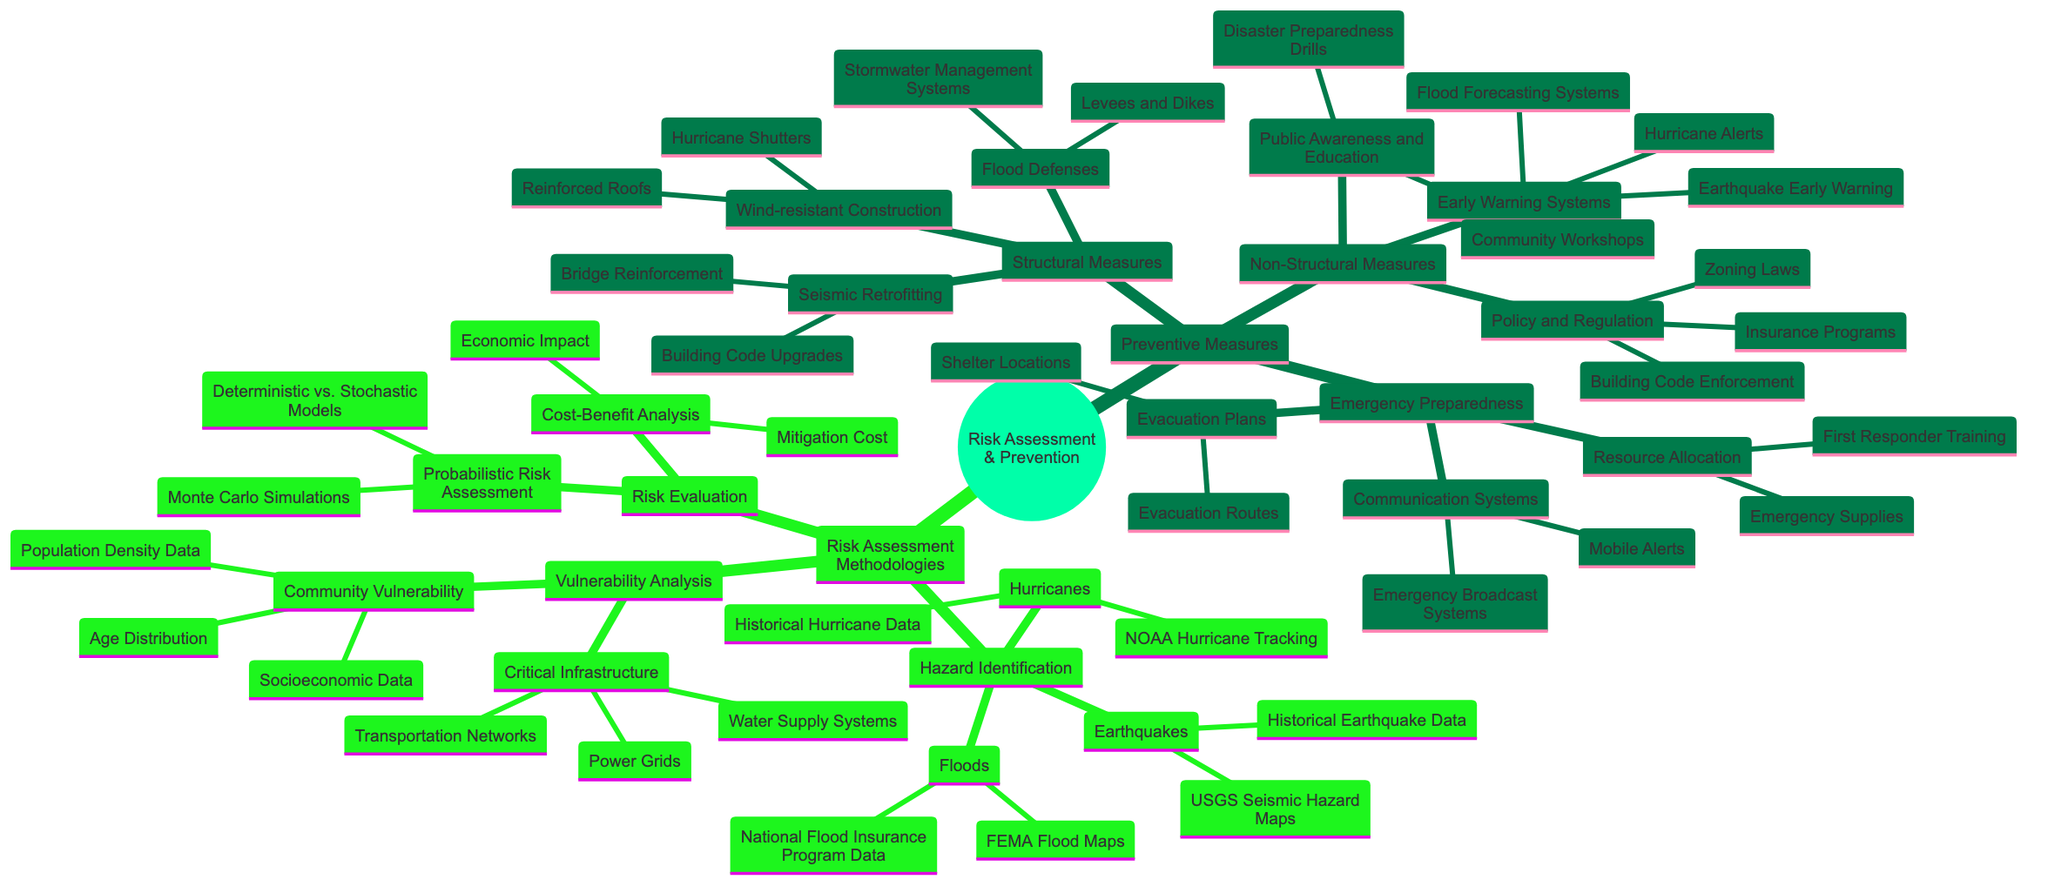What is the primary purpose of the concept map? The primary purpose of the concept map is to visually outline the comprehensive methodologies for risk assessment and preventive measures related to natural disasters. It provides a structured arrangement of categories and specific elements within those categories.
Answer: Risk Assessment and Prevention How many types of risk assessment methodologies are there? There are three main types of risk assessment methodologies identified in the diagram: Hazard Identification, Vulnerability Analysis, and Risk Evaluation.
Answer: 3 What are the two categories of preventive measures listed? The two main categories of preventive measures shown in the diagram are Structural Measures and Non-Structural Measures.
Answer: Structural Measures and Non-Structural Measures Name one type of early warning system mentioned. The diagram lists Earthquake Early Warning as one type of early warning system.
Answer: Earthquake Early Warning What data sources are used for Hazard Identification of floods? The data sources for Hazard Identification of floods include FEMA Flood Maps and National Flood Insurance Program Data.
Answer: FEMA Flood Maps and National Flood Insurance Program Data What does the term "Vulnerability Analysis" encompass? Vulnerability Analysis encompasses two significant areas: Critical Infrastructure and Community Vulnerability, each with specific data types related to infrastructure and demographics.
Answer: Critical Infrastructure and Community Vulnerability Which method is used for probabilistic risk assessment? Monte Carlo Simulations are one of the methods used for probabilistic risk assessment as indicated in the diagram.
Answer: Monte Carlo Simulations How do the preventive measures relate to emergency preparedness? Preventive measures include not only structural and non-structural approaches but also emergency preparedness strategies, which together aim to enhance resilience against natural disasters, ensuring a comprehensive strategy.
Answer: Emergency Preparedness What is one example of a structural measure for flood defenses? One example of a structural measure for flood defenses is Levees and Dikes, which are designed to control and manage floodwaters.
Answer: Levees and Dikes 